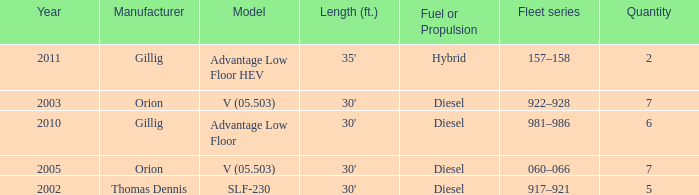Name the fleet series with a quantity of 5 917–921. 